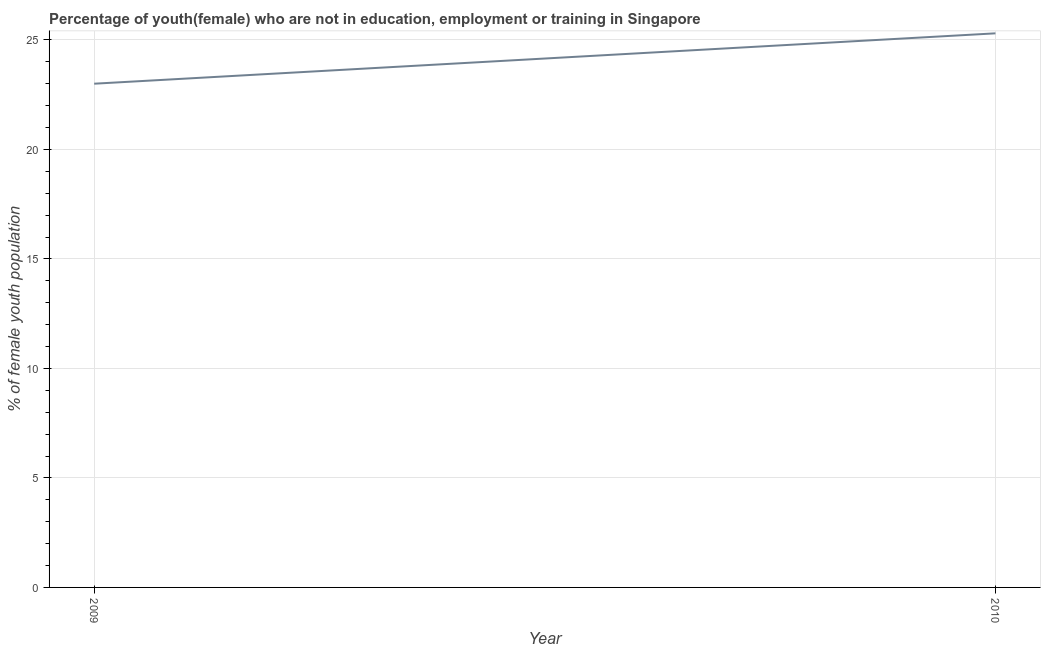What is the unemployed female youth population in 2010?
Your answer should be compact. 25.3. Across all years, what is the maximum unemployed female youth population?
Provide a succinct answer. 25.3. In which year was the unemployed female youth population maximum?
Provide a succinct answer. 2010. What is the sum of the unemployed female youth population?
Provide a succinct answer. 48.3. What is the difference between the unemployed female youth population in 2009 and 2010?
Provide a short and direct response. -2.3. What is the average unemployed female youth population per year?
Offer a terse response. 24.15. What is the median unemployed female youth population?
Your answer should be compact. 24.15. What is the ratio of the unemployed female youth population in 2009 to that in 2010?
Offer a terse response. 0.91. Is the unemployed female youth population in 2009 less than that in 2010?
Your answer should be compact. Yes. In how many years, is the unemployed female youth population greater than the average unemployed female youth population taken over all years?
Give a very brief answer. 1. How many lines are there?
Make the answer very short. 1. How many years are there in the graph?
Provide a succinct answer. 2. What is the difference between two consecutive major ticks on the Y-axis?
Your response must be concise. 5. Are the values on the major ticks of Y-axis written in scientific E-notation?
Give a very brief answer. No. Does the graph contain any zero values?
Give a very brief answer. No. What is the title of the graph?
Your answer should be very brief. Percentage of youth(female) who are not in education, employment or training in Singapore. What is the label or title of the Y-axis?
Ensure brevity in your answer.  % of female youth population. What is the % of female youth population of 2010?
Make the answer very short. 25.3. What is the difference between the % of female youth population in 2009 and 2010?
Your answer should be very brief. -2.3. What is the ratio of the % of female youth population in 2009 to that in 2010?
Keep it short and to the point. 0.91. 